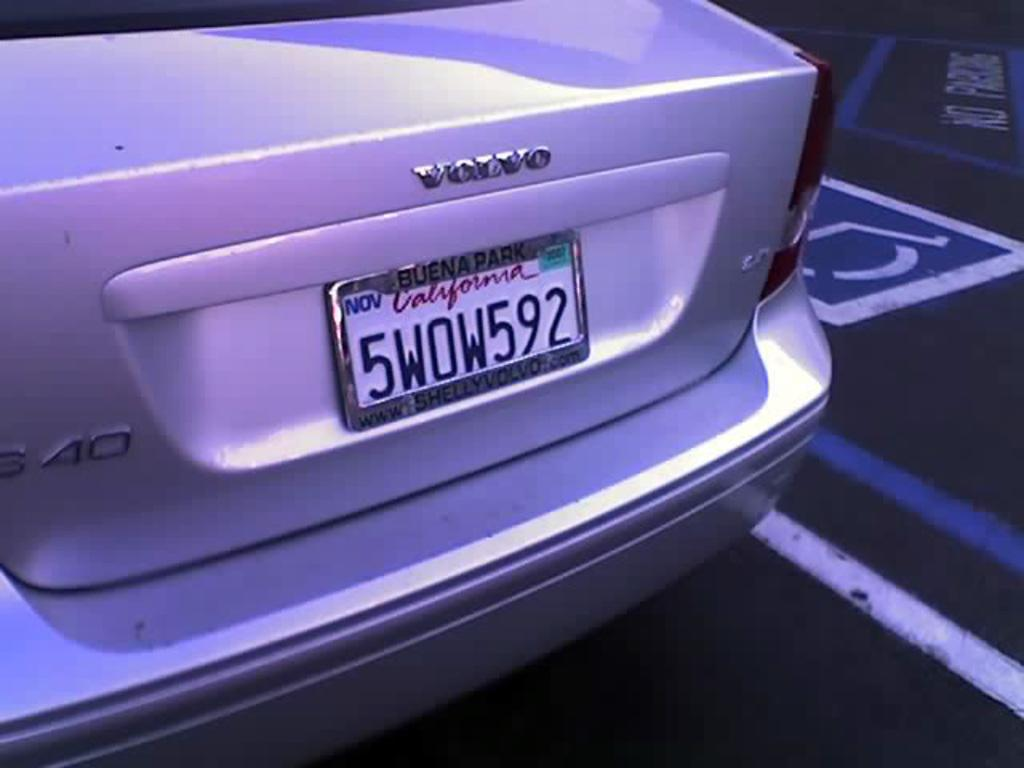<image>
Summarize the visual content of the image. a purple volvo with a California plate beginning with 5. 